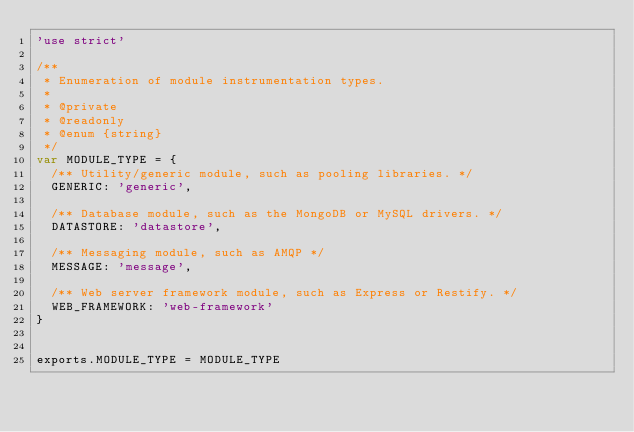<code> <loc_0><loc_0><loc_500><loc_500><_JavaScript_>'use strict'

/**
 * Enumeration of module instrumentation types.
 *
 * @private
 * @readonly
 * @enum {string}
 */
var MODULE_TYPE = {
  /** Utility/generic module, such as pooling libraries. */
  GENERIC: 'generic',

  /** Database module, such as the MongoDB or MySQL drivers. */
  DATASTORE: 'datastore',

  /** Messaging module, such as AMQP */
  MESSAGE: 'message',

  /** Web server framework module, such as Express or Restify. */
  WEB_FRAMEWORK: 'web-framework'
}


exports.MODULE_TYPE = MODULE_TYPE
</code> 